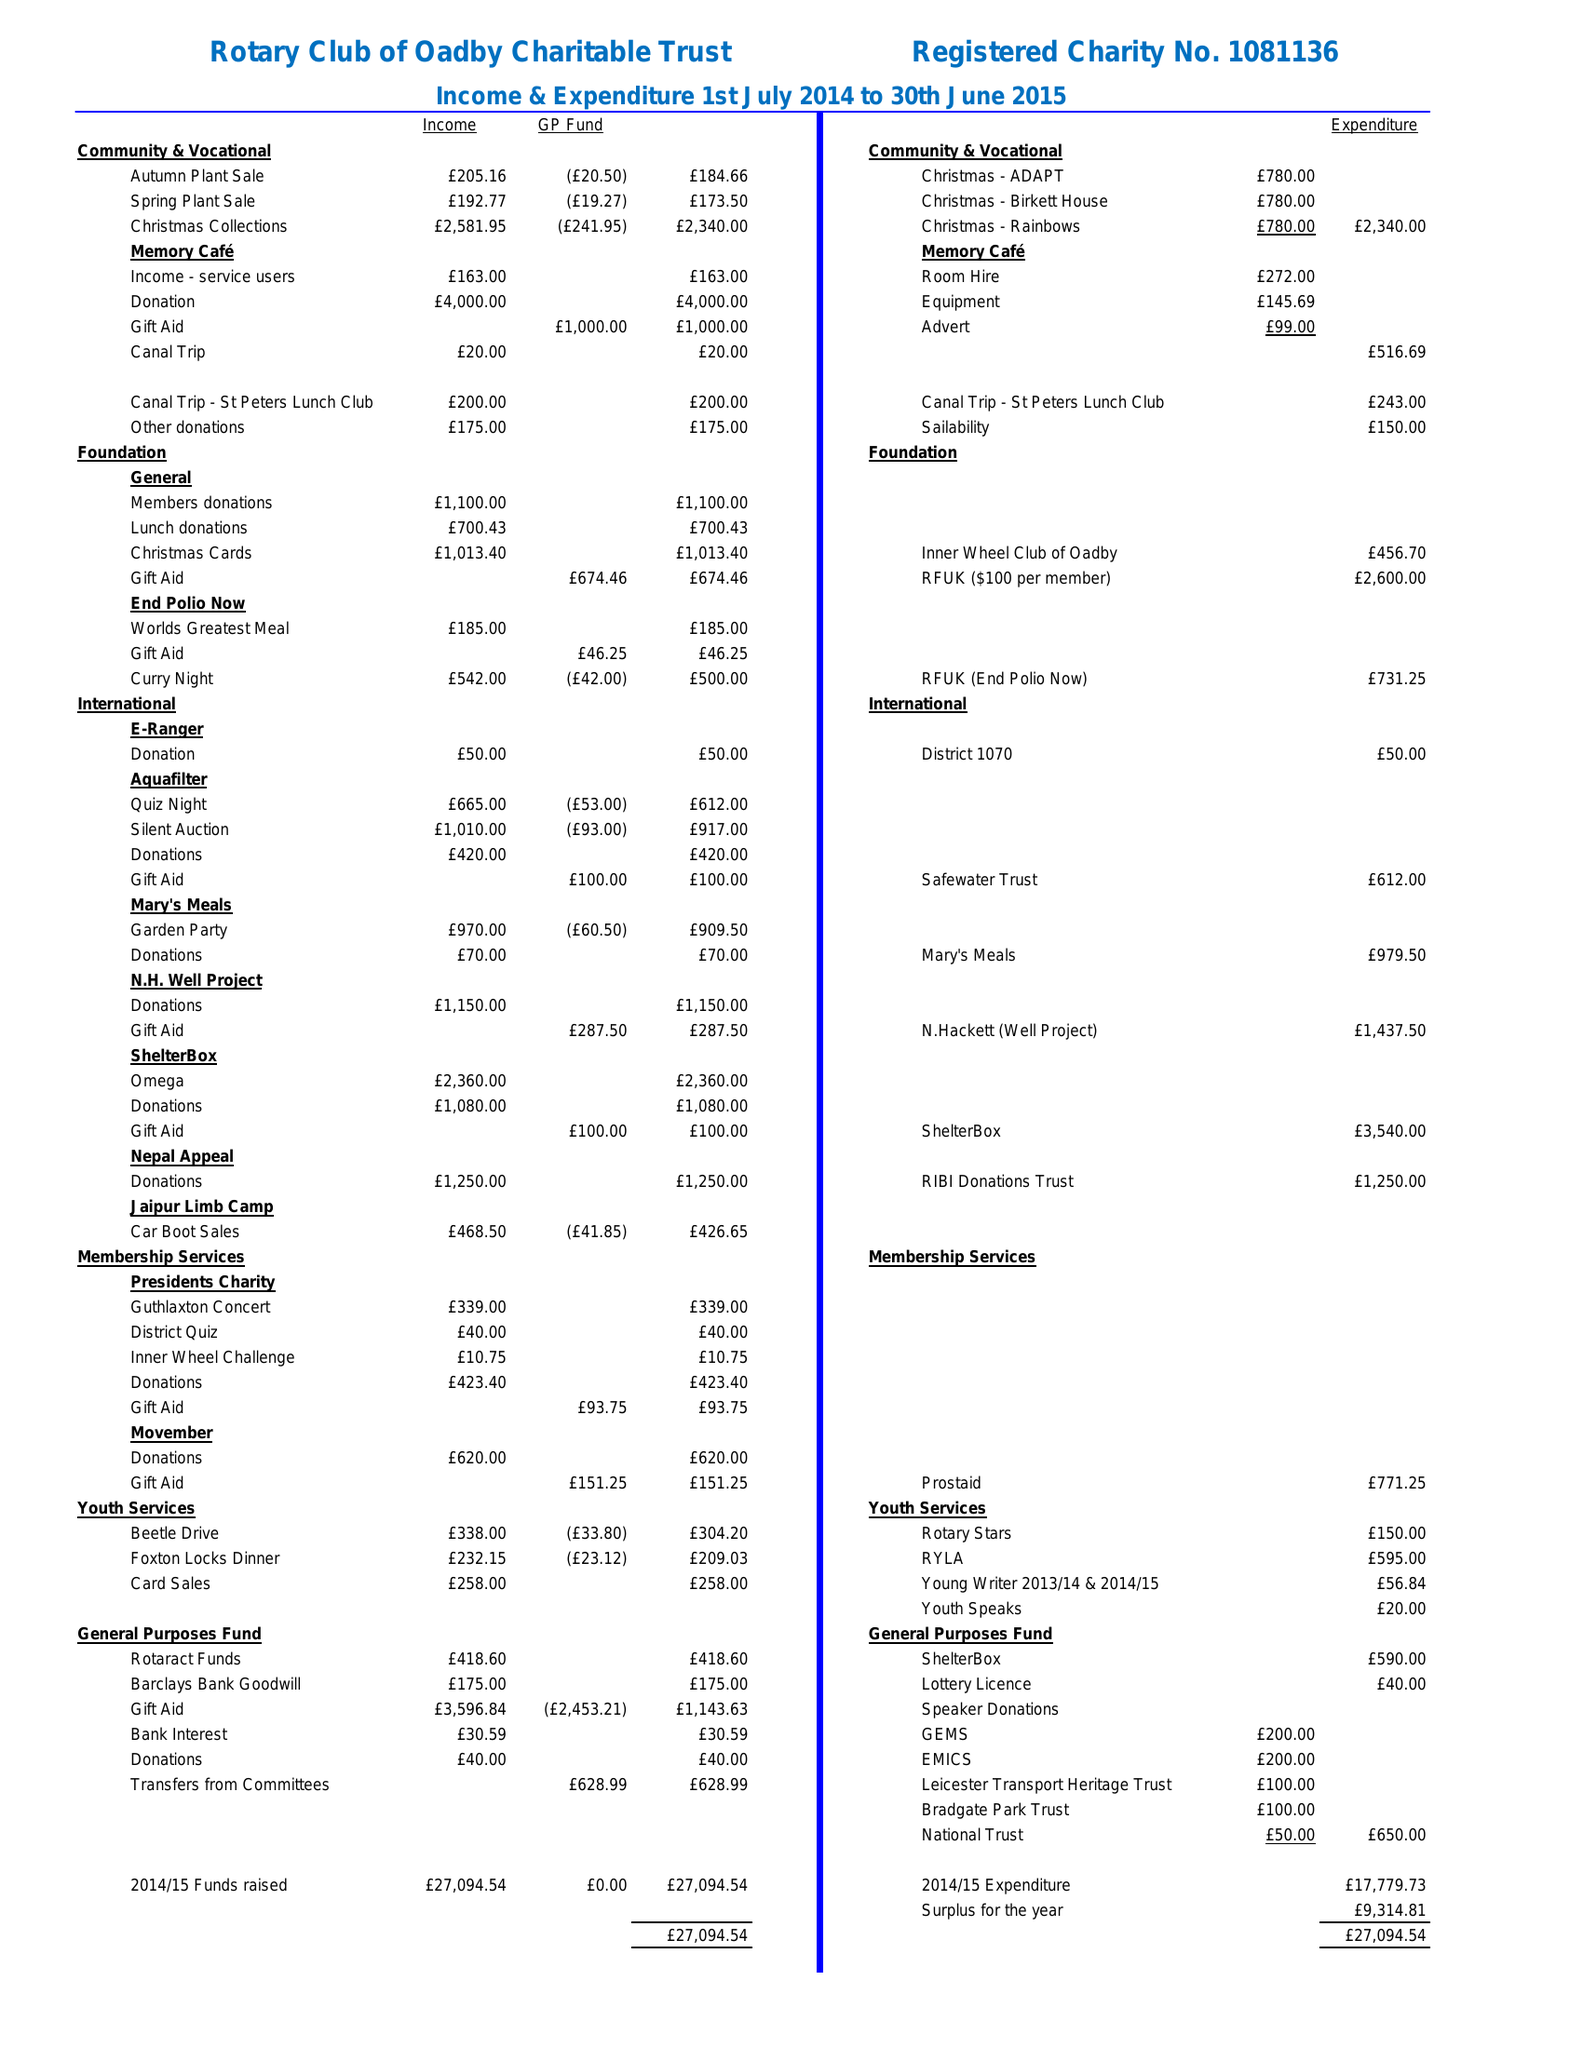What is the value for the spending_annually_in_british_pounds?
Answer the question using a single word or phrase. 17779.00 